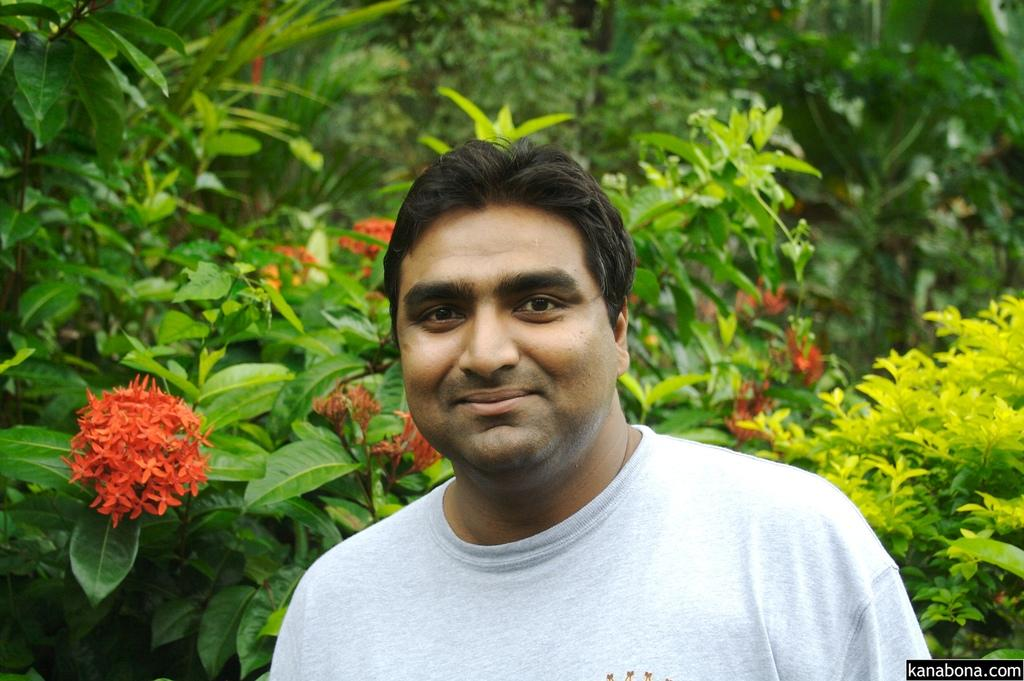Who is present in the image? There is a man in the image. What is the man wearing? The man is wearing a t-shirt. What is the man's facial expression? The man is smiling. What can be seen in the background of the image? There are trees with red flowers in the background of the image. What type of card is the man holding in the image? There is no card present in the image; the man is not holding anything. 